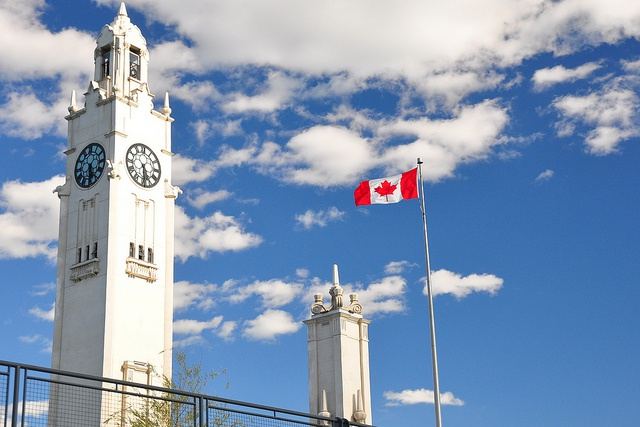Describe the objects in this image and their specific colors. I can see clock in darkgray, white, and gray tones and clock in darkgray, black, teal, and blue tones in this image. 